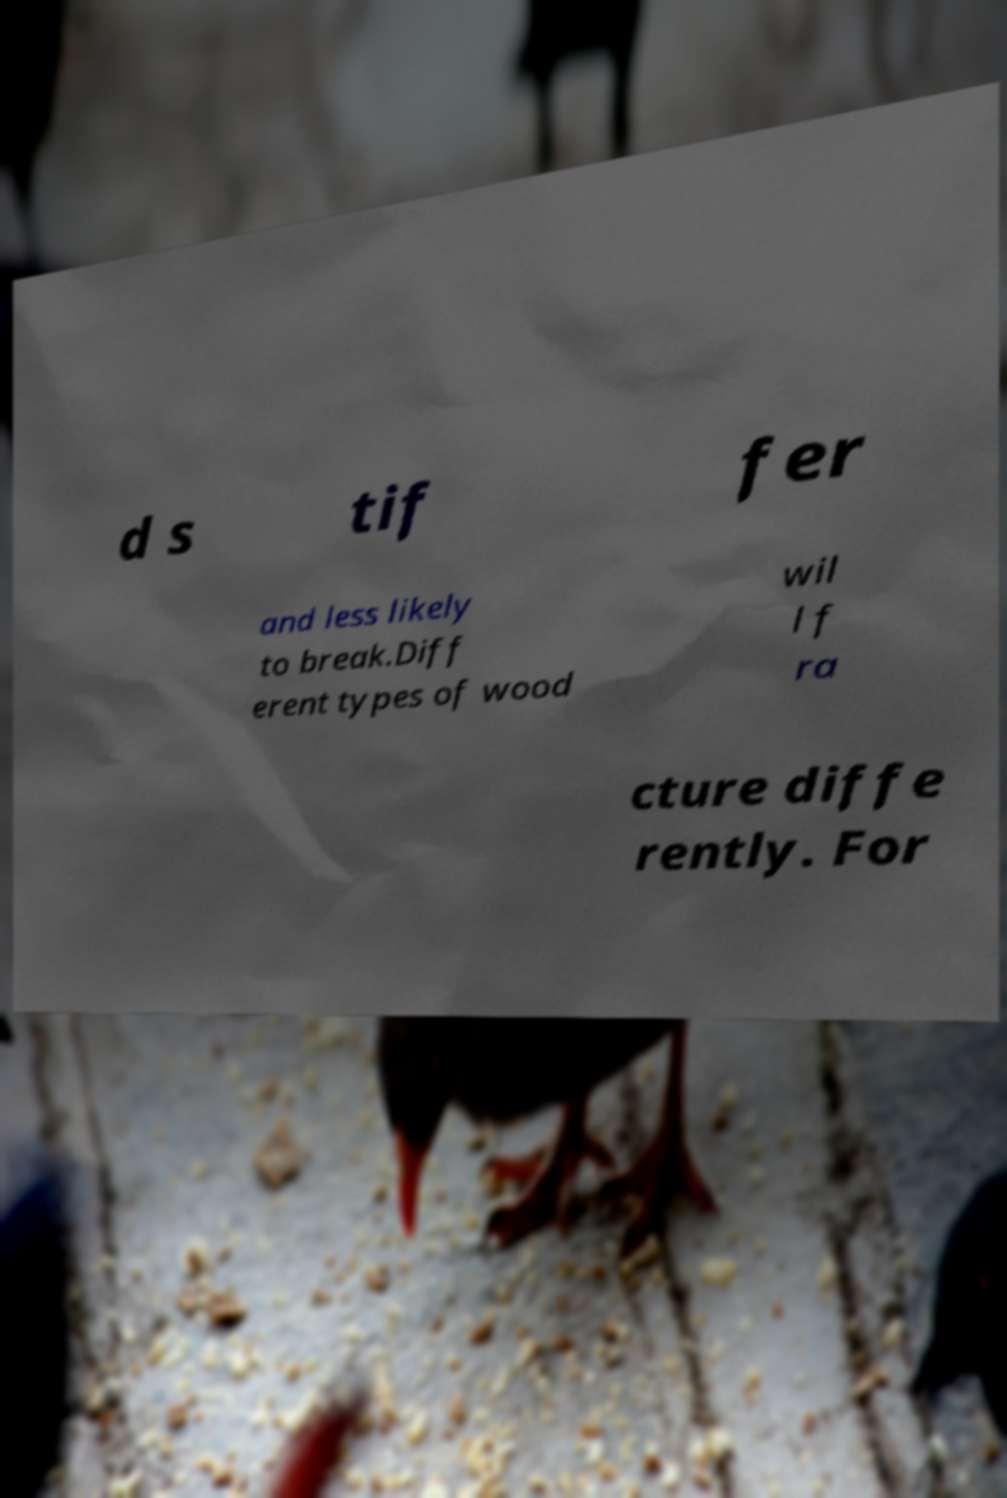Could you extract and type out the text from this image? d s tif fer and less likely to break.Diff erent types of wood wil l f ra cture diffe rently. For 